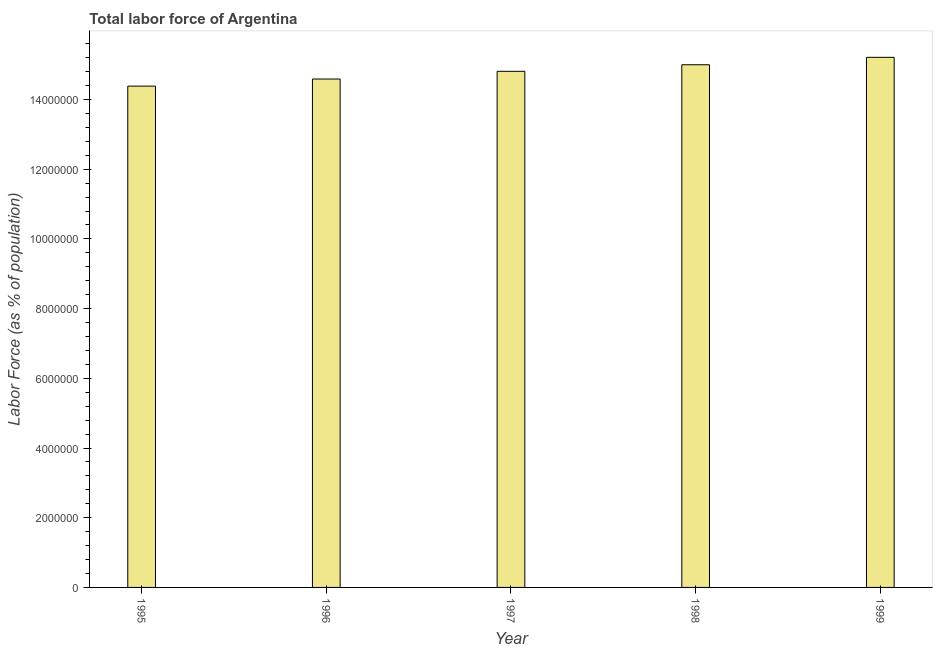What is the title of the graph?
Give a very brief answer. Total labor force of Argentina. What is the label or title of the X-axis?
Offer a very short reply. Year. What is the label or title of the Y-axis?
Give a very brief answer. Labor Force (as % of population). What is the total labor force in 1995?
Offer a terse response. 1.44e+07. Across all years, what is the maximum total labor force?
Your answer should be very brief. 1.52e+07. Across all years, what is the minimum total labor force?
Provide a succinct answer. 1.44e+07. In which year was the total labor force maximum?
Make the answer very short. 1999. In which year was the total labor force minimum?
Your answer should be compact. 1995. What is the sum of the total labor force?
Give a very brief answer. 7.40e+07. What is the difference between the total labor force in 1997 and 1999?
Provide a succinct answer. -4.01e+05. What is the average total labor force per year?
Give a very brief answer. 1.48e+07. What is the median total labor force?
Offer a very short reply. 1.48e+07. In how many years, is the total labor force greater than 12800000 %?
Your response must be concise. 5. Do a majority of the years between 1995 and 1996 (inclusive) have total labor force greater than 4800000 %?
Your answer should be compact. Yes. Is the total labor force in 1995 less than that in 1999?
Your answer should be compact. Yes. Is the difference between the total labor force in 1995 and 1999 greater than the difference between any two years?
Ensure brevity in your answer.  Yes. What is the difference between the highest and the second highest total labor force?
Provide a succinct answer. 2.13e+05. Is the sum of the total labor force in 1997 and 1999 greater than the maximum total labor force across all years?
Offer a terse response. Yes. What is the difference between the highest and the lowest total labor force?
Make the answer very short. 8.26e+05. In how many years, is the total labor force greater than the average total labor force taken over all years?
Offer a very short reply. 3. Are all the bars in the graph horizontal?
Give a very brief answer. No. How many years are there in the graph?
Give a very brief answer. 5. What is the difference between two consecutive major ticks on the Y-axis?
Make the answer very short. 2.00e+06. Are the values on the major ticks of Y-axis written in scientific E-notation?
Keep it short and to the point. No. What is the Labor Force (as % of population) of 1995?
Your answer should be very brief. 1.44e+07. What is the Labor Force (as % of population) of 1996?
Make the answer very short. 1.46e+07. What is the Labor Force (as % of population) of 1997?
Give a very brief answer. 1.48e+07. What is the Labor Force (as % of population) of 1998?
Offer a terse response. 1.50e+07. What is the Labor Force (as % of population) of 1999?
Make the answer very short. 1.52e+07. What is the difference between the Labor Force (as % of population) in 1995 and 1996?
Keep it short and to the point. -2.04e+05. What is the difference between the Labor Force (as % of population) in 1995 and 1997?
Provide a succinct answer. -4.25e+05. What is the difference between the Labor Force (as % of population) in 1995 and 1998?
Ensure brevity in your answer.  -6.14e+05. What is the difference between the Labor Force (as % of population) in 1995 and 1999?
Your answer should be very brief. -8.26e+05. What is the difference between the Labor Force (as % of population) in 1996 and 1997?
Give a very brief answer. -2.21e+05. What is the difference between the Labor Force (as % of population) in 1996 and 1998?
Give a very brief answer. -4.09e+05. What is the difference between the Labor Force (as % of population) in 1996 and 1999?
Your response must be concise. -6.22e+05. What is the difference between the Labor Force (as % of population) in 1997 and 1998?
Provide a succinct answer. -1.88e+05. What is the difference between the Labor Force (as % of population) in 1997 and 1999?
Make the answer very short. -4.01e+05. What is the difference between the Labor Force (as % of population) in 1998 and 1999?
Make the answer very short. -2.13e+05. What is the ratio of the Labor Force (as % of population) in 1995 to that in 1997?
Provide a short and direct response. 0.97. What is the ratio of the Labor Force (as % of population) in 1995 to that in 1998?
Provide a short and direct response. 0.96. What is the ratio of the Labor Force (as % of population) in 1995 to that in 1999?
Give a very brief answer. 0.95. What is the ratio of the Labor Force (as % of population) in 1996 to that in 1998?
Your response must be concise. 0.97. What is the ratio of the Labor Force (as % of population) in 1996 to that in 1999?
Provide a short and direct response. 0.96. 